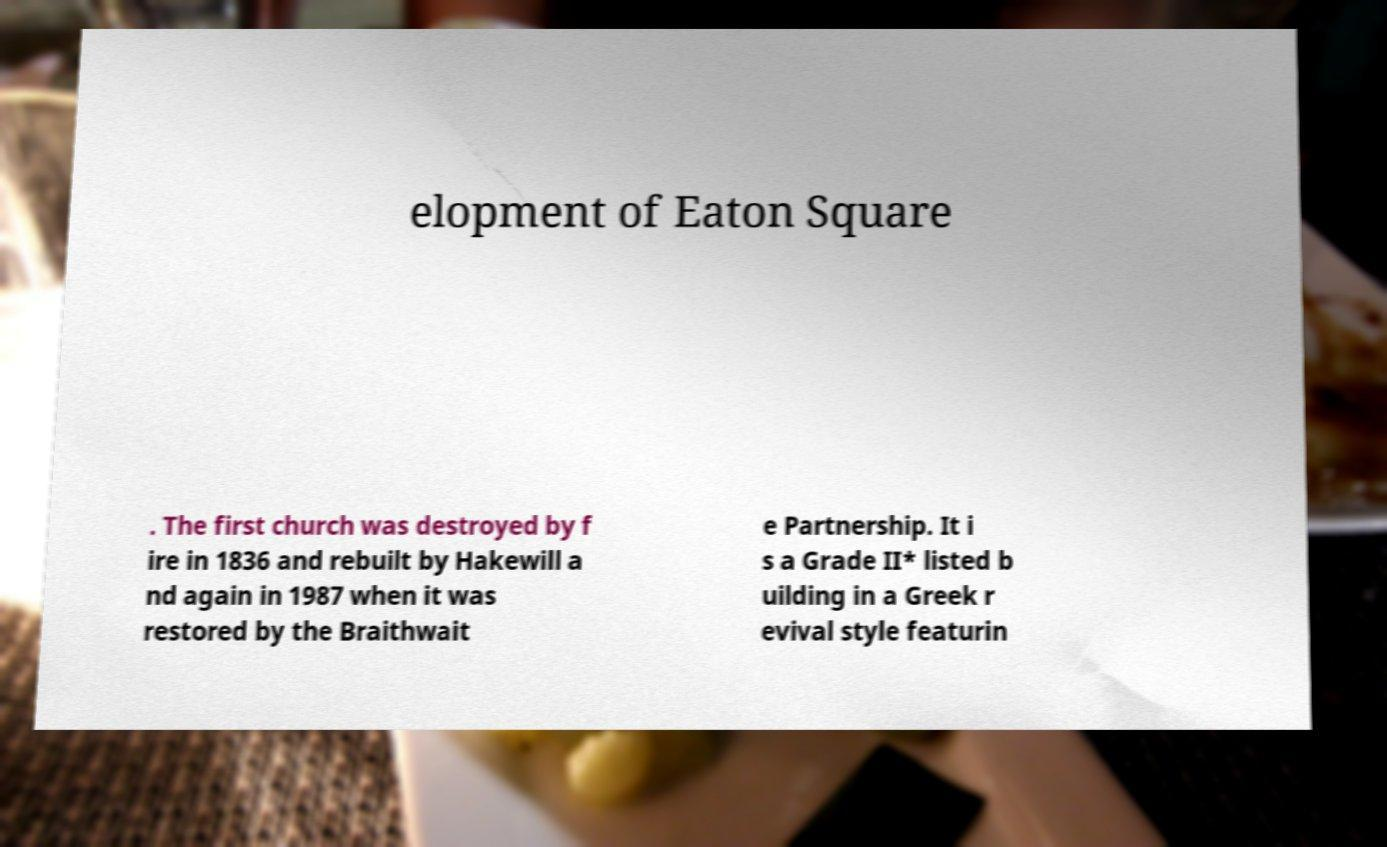For documentation purposes, I need the text within this image transcribed. Could you provide that? elopment of Eaton Square . The first church was destroyed by f ire in 1836 and rebuilt by Hakewill a nd again in 1987 when it was restored by the Braithwait e Partnership. It i s a Grade II* listed b uilding in a Greek r evival style featurin 